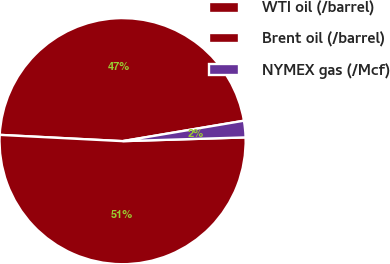Convert chart. <chart><loc_0><loc_0><loc_500><loc_500><pie_chart><fcel>WTI oil (/barrel)<fcel>Brent oil (/barrel)<fcel>NYMEX gas (/Mcf)<nl><fcel>46.53%<fcel>51.3%<fcel>2.17%<nl></chart> 